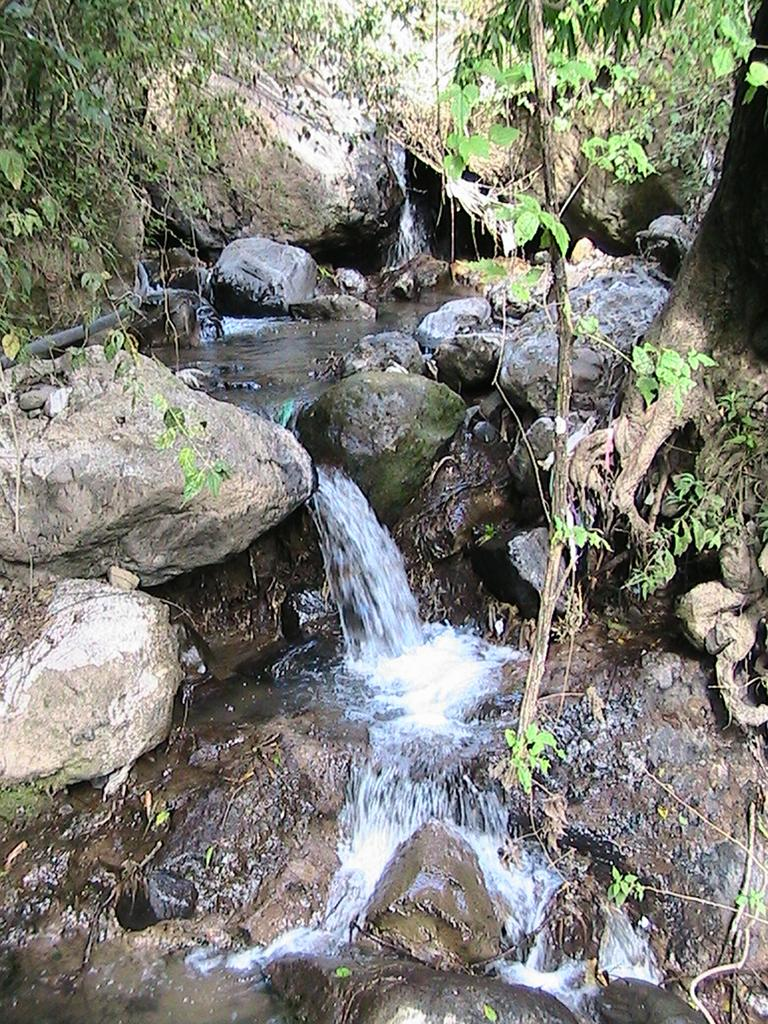What type of natural formation can be seen in the image? There are rocks in the image. What is happening to the water in the image? Water is flowing through the rocks. What type of vegetation is present in the area around the rocks and water? There are trees in the area around the rocks and water. What type of doctor is examining the wrist in the image? There is no doctor or wrist present in the image; it features rocks and flowing water with trees in the background. 